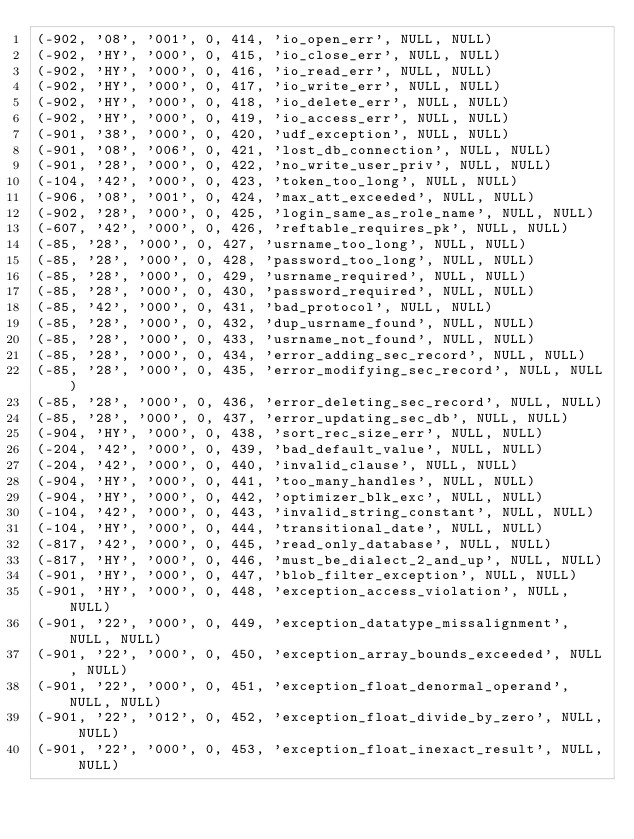Convert code to text. <code><loc_0><loc_0><loc_500><loc_500><_SQL_>(-902, '08', '001', 0, 414, 'io_open_err', NULL, NULL)
(-902, 'HY', '000', 0, 415, 'io_close_err', NULL, NULL)
(-902, 'HY', '000', 0, 416, 'io_read_err', NULL, NULL)
(-902, 'HY', '000', 0, 417, 'io_write_err', NULL, NULL)
(-902, 'HY', '000', 0, 418, 'io_delete_err', NULL, NULL)
(-902, 'HY', '000', 0, 419, 'io_access_err', NULL, NULL)
(-901, '38', '000', 0, 420, 'udf_exception', NULL, NULL)
(-901, '08', '006', 0, 421, 'lost_db_connection', NULL, NULL)
(-901, '28', '000', 0, 422, 'no_write_user_priv', NULL, NULL)
(-104, '42', '000', 0, 423, 'token_too_long', NULL, NULL)
(-906, '08', '001', 0, 424, 'max_att_exceeded', NULL, NULL)
(-902, '28', '000', 0, 425, 'login_same_as_role_name', NULL, NULL)
(-607, '42', '000', 0, 426, 'reftable_requires_pk', NULL, NULL)
(-85, '28', '000', 0, 427, 'usrname_too_long', NULL, NULL)
(-85, '28', '000', 0, 428, 'password_too_long', NULL, NULL)
(-85, '28', '000', 0, 429, 'usrname_required', NULL, NULL)
(-85, '28', '000', 0, 430, 'password_required', NULL, NULL)
(-85, '42', '000', 0, 431, 'bad_protocol', NULL, NULL)
(-85, '28', '000', 0, 432, 'dup_usrname_found', NULL, NULL)
(-85, '28', '000', 0, 433, 'usrname_not_found', NULL, NULL)
(-85, '28', '000', 0, 434, 'error_adding_sec_record', NULL, NULL)
(-85, '28', '000', 0, 435, 'error_modifying_sec_record', NULL, NULL)
(-85, '28', '000', 0, 436, 'error_deleting_sec_record', NULL, NULL)
(-85, '28', '000', 0, 437, 'error_updating_sec_db', NULL, NULL)
(-904, 'HY', '000', 0, 438, 'sort_rec_size_err', NULL, NULL)
(-204, '42', '000', 0, 439, 'bad_default_value', NULL, NULL)
(-204, '42', '000', 0, 440, 'invalid_clause', NULL, NULL)
(-904, 'HY', '000', 0, 441, 'too_many_handles', NULL, NULL)
(-904, 'HY', '000', 0, 442, 'optimizer_blk_exc', NULL, NULL)
(-104, '42', '000', 0, 443, 'invalid_string_constant', NULL, NULL)
(-104, 'HY', '000', 0, 444, 'transitional_date', NULL, NULL)
(-817, '42', '000', 0, 445, 'read_only_database', NULL, NULL)
(-817, 'HY', '000', 0, 446, 'must_be_dialect_2_and_up', NULL, NULL)
(-901, 'HY', '000', 0, 447, 'blob_filter_exception', NULL, NULL)
(-901, 'HY', '000', 0, 448, 'exception_access_violation', NULL, NULL)
(-901, '22', '000', 0, 449, 'exception_datatype_missalignment', NULL, NULL)
(-901, '22', '000', 0, 450, 'exception_array_bounds_exceeded', NULL, NULL)
(-901, '22', '000', 0, 451, 'exception_float_denormal_operand', NULL, NULL)
(-901, '22', '012', 0, 452, 'exception_float_divide_by_zero', NULL, NULL)
(-901, '22', '000', 0, 453, 'exception_float_inexact_result', NULL, NULL)</code> 